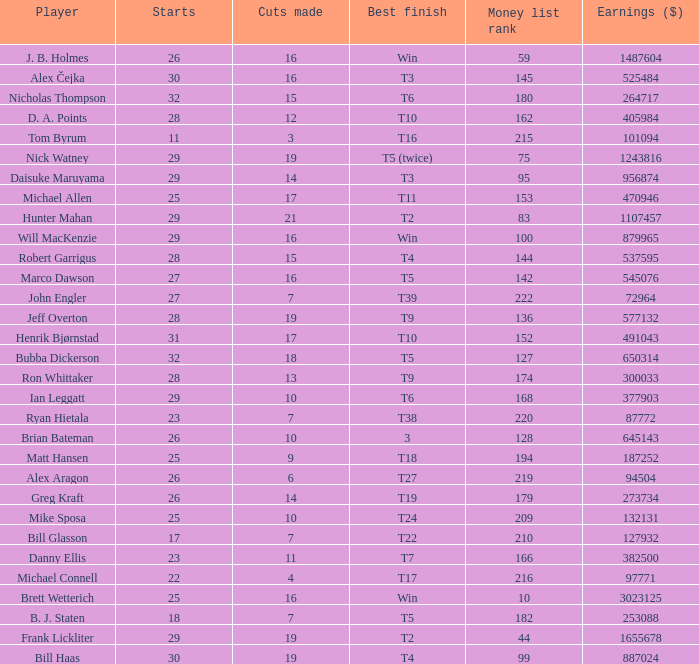What is the maximum money list rank for Matt Hansen? 194.0. 